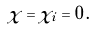<formula> <loc_0><loc_0><loc_500><loc_500>\chi = \chi _ { i } = 0 \, .</formula> 